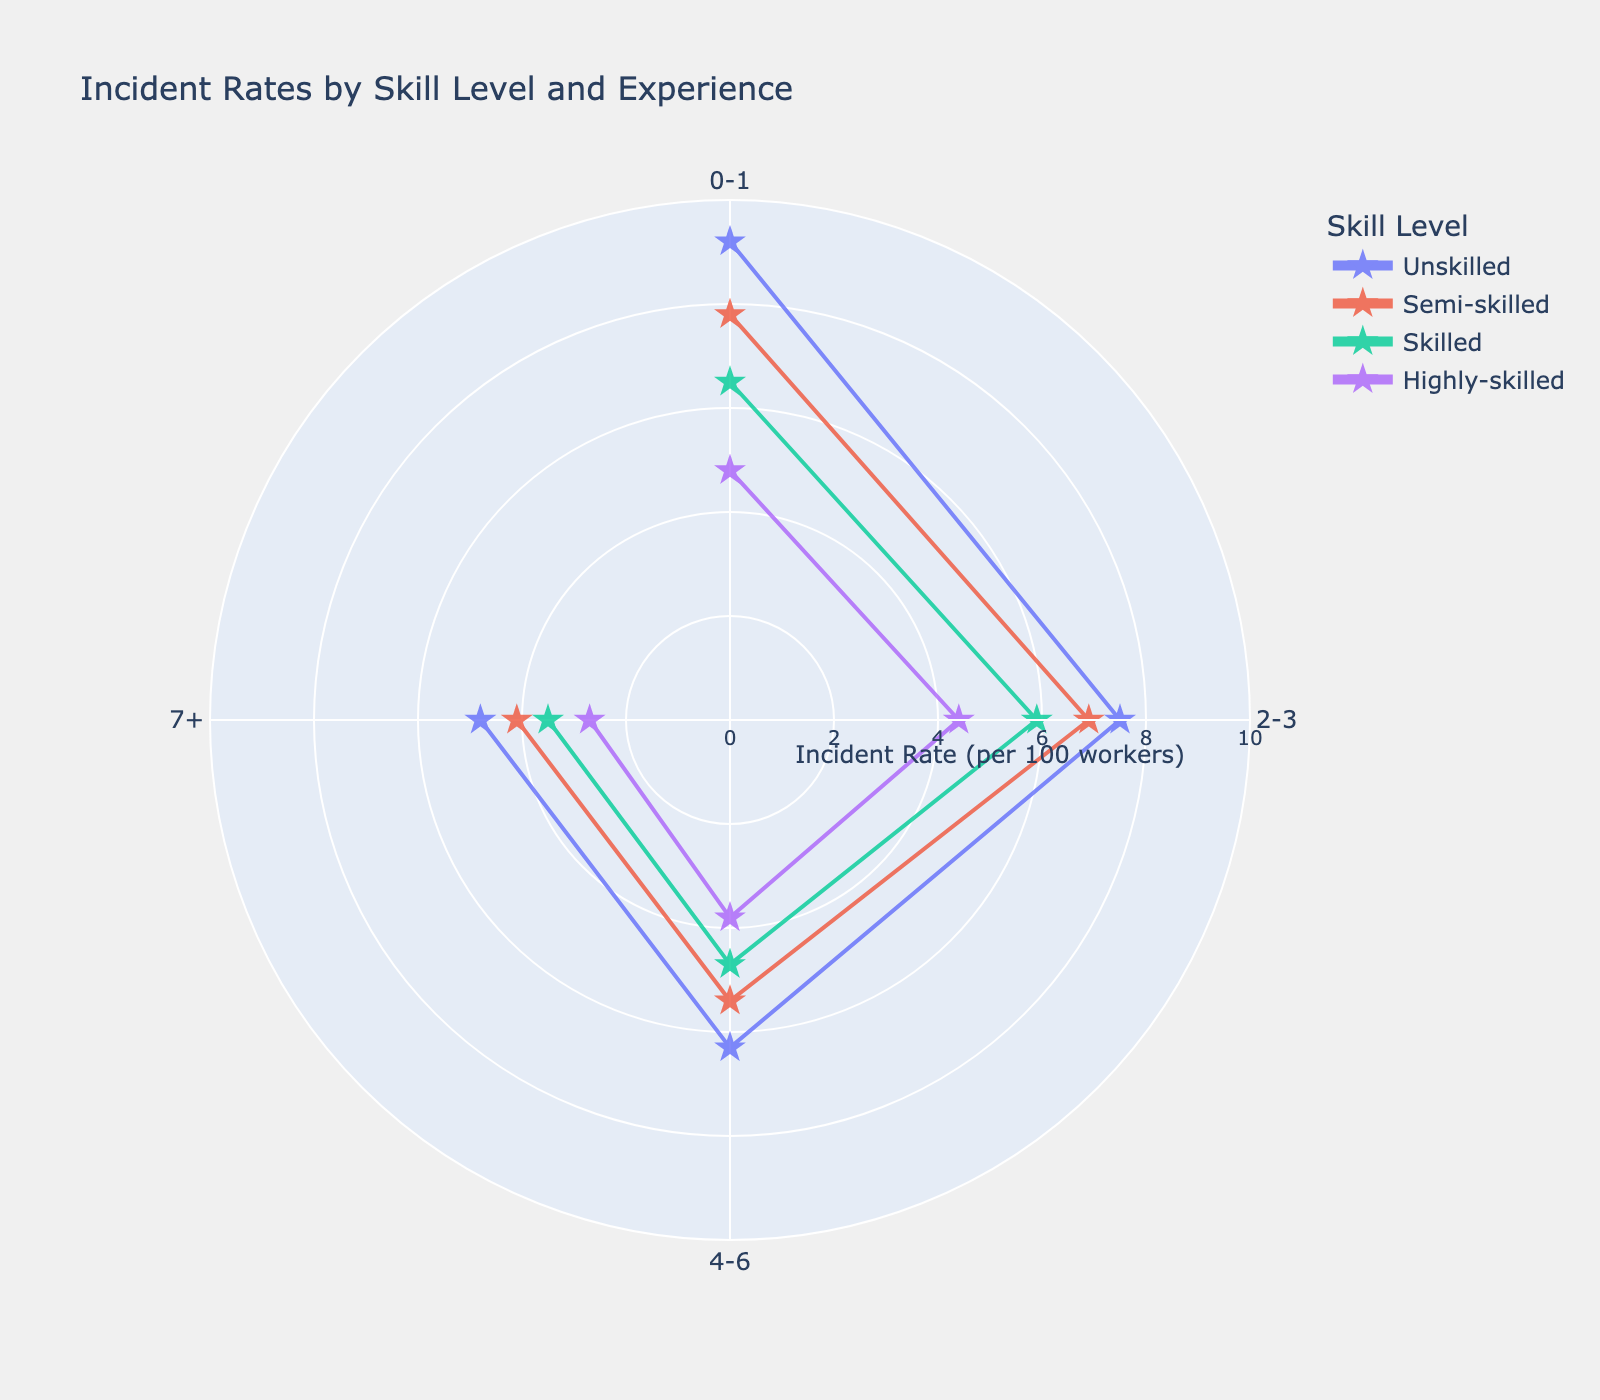What is the range of the radial axis in the figure? The radial axis range can be observed from the annotations around the axis, which show that the values go from 0 to 10.
Answer: 0 to 10 Which skill level has the highest incident rate for the 0-1 years experience category? To determine the highest incident rate for the 0-1 years experience, look at the points for each skill level at "0-1" on the angular axis. The values are 9.2 for Unskilled, 7.8 for Semi-skilled, 6.5 for Skilled, and 4.8 for Highly-skilled. The highest value is 9.2, which corresponds to Unskilled.
Answer: Unskilled Is there any skill level that has a decreasing trend in incident rates as experience increases? To identify if any skill level shows a decreasing trend in incident rates, look at the lines connecting points for each skill level. For all skill levels (Unskilled, Semi-skilled, Skilled, Highly-skilled), the incident rates decrease as experience increases, indicating a decreasing trend for each.
Answer: Yes, all skill levels How does the incident rate for Skilled workers with 4-6 years of experience compare to that of Highly-skilled workers with 4-6 years of experience? Compare the incident rate for Skilled workers (4-6 years experience) and Highly-skilled workers (4-6 years experience). The observed values are 4.7 for Skilled and 3.8 for Highly-skilled. Thus, the incident rate for Skilled workers is higher.
Answer: Skilled workers have a higher incident rate What is the average incident rate for Semi-skilled workers across all experience levels? To calculate the average incident rate for Semi-skilled workers, sum the incident rates (7.8, 6.9, 5.4, 4.1) and then divide by the number of experience levels. (7.8 + 6.9 + 5.4 + 4.1) / 4 = 24.2 / 4 = 6.05
Answer: 6.05 Which experience level generally has the lowest incident rates across all skill levels? Compare the incident rates for each experience level across all skill levels. The lowest rates for each category are 4.8 (Unskilled), 4.1 (Semi-skilled), 3.5 (Skilled), and 2.7 (Highly-skilled) for the 7+ years experience category. Thus, 7+ years experience has the lowest incident rates generally.
Answer: 7+ How many data points are represented in the figure? There are 4 skill levels and 4 experience levels, making a total of 4 x 4 = 16 data points in the figure.
Answer: 16 Which skill level shows the smallest change in incident rates between the 0-1 years and the 7+ years experience categories? Calculate the difference in incident rates between 0-1 years and 7+ years for each skill level: 
- Unskilled: 9.2 - 4.8 = 4.4 
- Semi-skilled: 7.8 - 4.1 = 3.7
- Skilled: 6.5 - 3.5 = 3
- Highly-skilled: 4.8 - 2.7 = 2.1 
The smallest change is for Highly-skilled workers.
Answer: Highly-skilled 